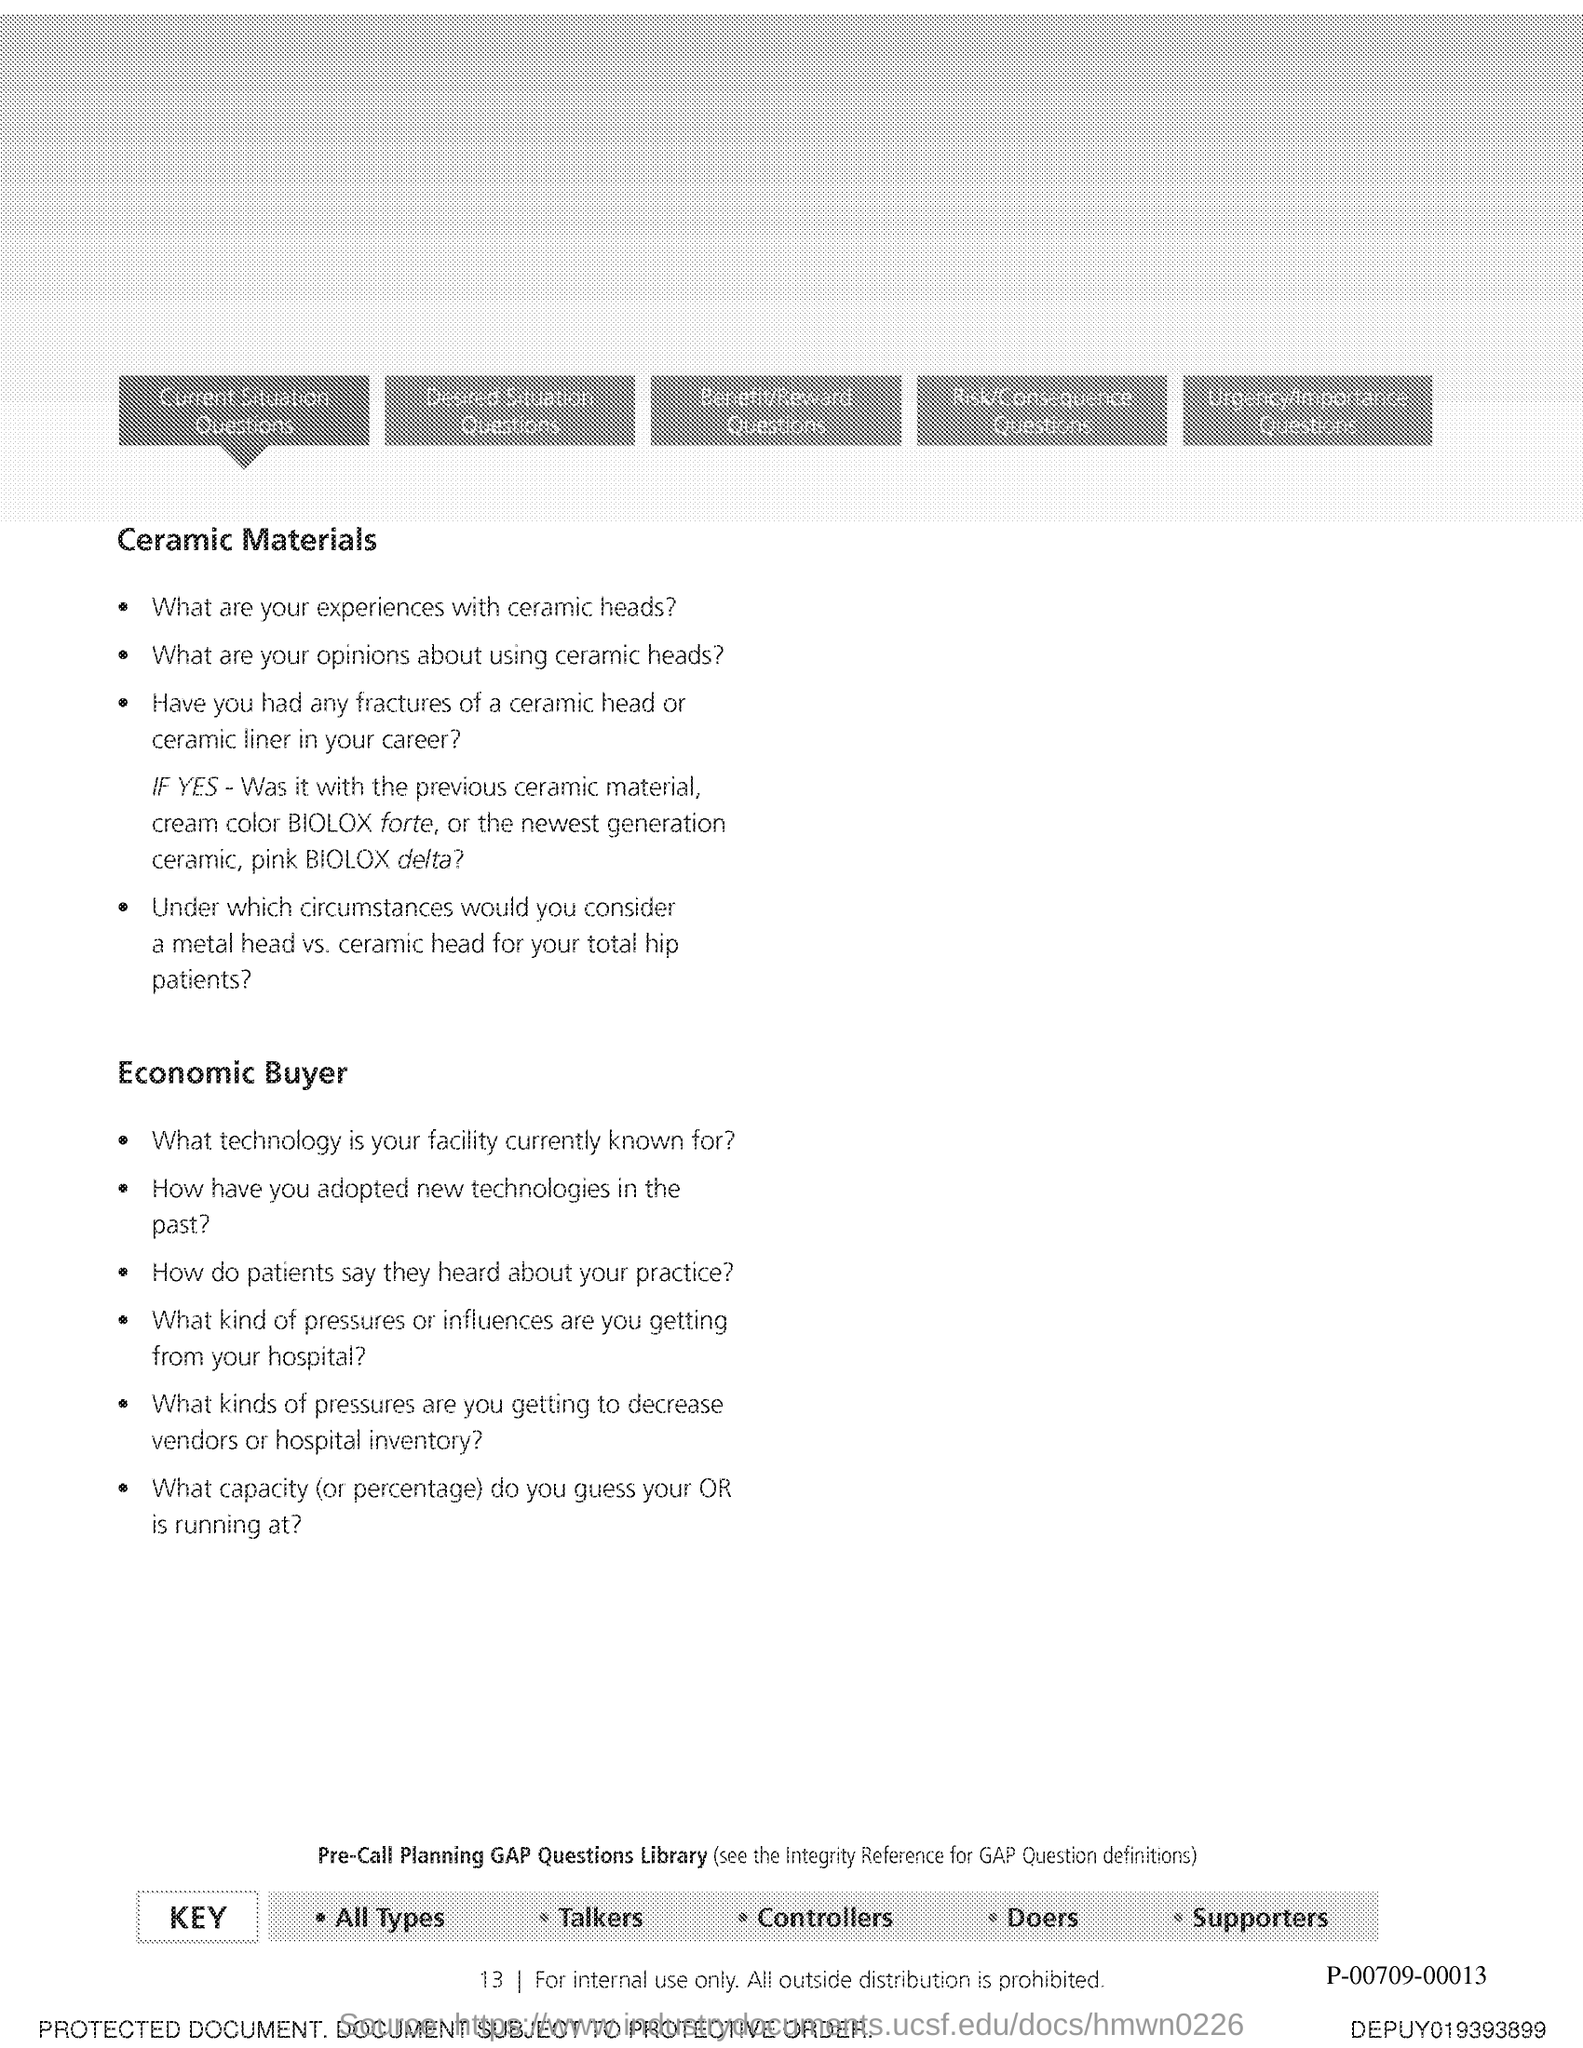What is the Page Number?
Give a very brief answer. 13. 